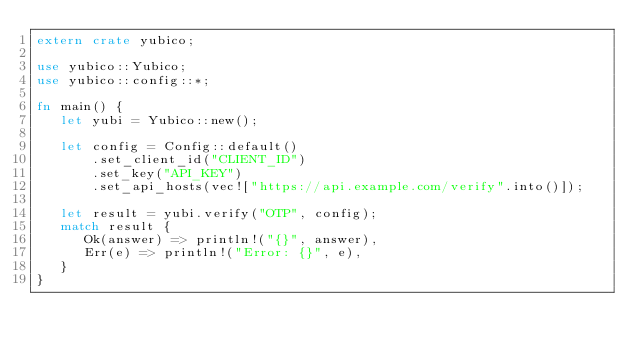<code> <loc_0><loc_0><loc_500><loc_500><_Rust_>extern crate yubico;

use yubico::Yubico;
use yubico::config::*;

fn main() {
   let yubi = Yubico::new();

   let config = Config::default()
       .set_client_id("CLIENT_ID")
       .set_key("API_KEY")
       .set_api_hosts(vec!["https://api.example.com/verify".into()]);

   let result = yubi.verify("OTP", config);
   match result {
      Ok(answer) => println!("{}", answer),
      Err(e) => println!("Error: {}", e),
   }
}</code> 